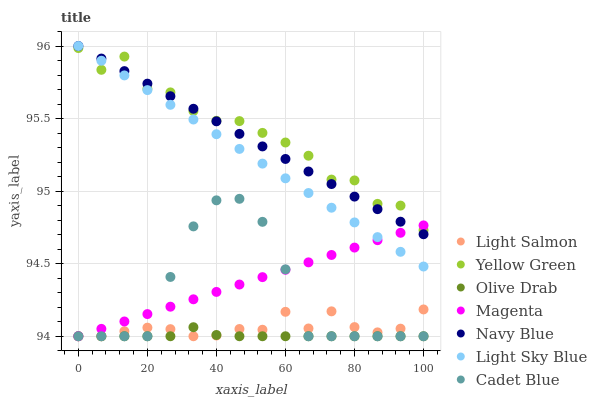Does Olive Drab have the minimum area under the curve?
Answer yes or no. Yes. Does Yellow Green have the maximum area under the curve?
Answer yes or no. Yes. Does Cadet Blue have the minimum area under the curve?
Answer yes or no. No. Does Cadet Blue have the maximum area under the curve?
Answer yes or no. No. Is Magenta the smoothest?
Answer yes or no. Yes. Is Yellow Green the roughest?
Answer yes or no. Yes. Is Cadet Blue the smoothest?
Answer yes or no. No. Is Cadet Blue the roughest?
Answer yes or no. No. Does Light Salmon have the lowest value?
Answer yes or no. Yes. Does Yellow Green have the lowest value?
Answer yes or no. No. Does Light Sky Blue have the highest value?
Answer yes or no. Yes. Does Cadet Blue have the highest value?
Answer yes or no. No. Is Olive Drab less than Yellow Green?
Answer yes or no. Yes. Is Light Sky Blue greater than Cadet Blue?
Answer yes or no. Yes. Does Magenta intersect Cadet Blue?
Answer yes or no. Yes. Is Magenta less than Cadet Blue?
Answer yes or no. No. Is Magenta greater than Cadet Blue?
Answer yes or no. No. Does Olive Drab intersect Yellow Green?
Answer yes or no. No. 